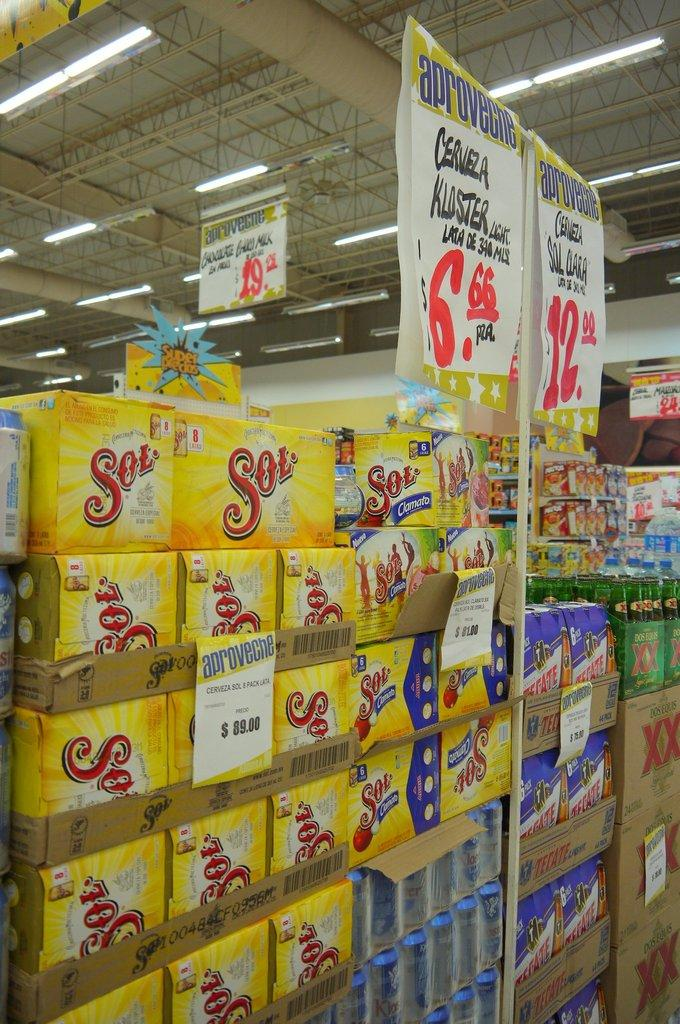<image>
Present a compact description of the photo's key features. A grocery store with several boxes of Sol beer stacked up. 